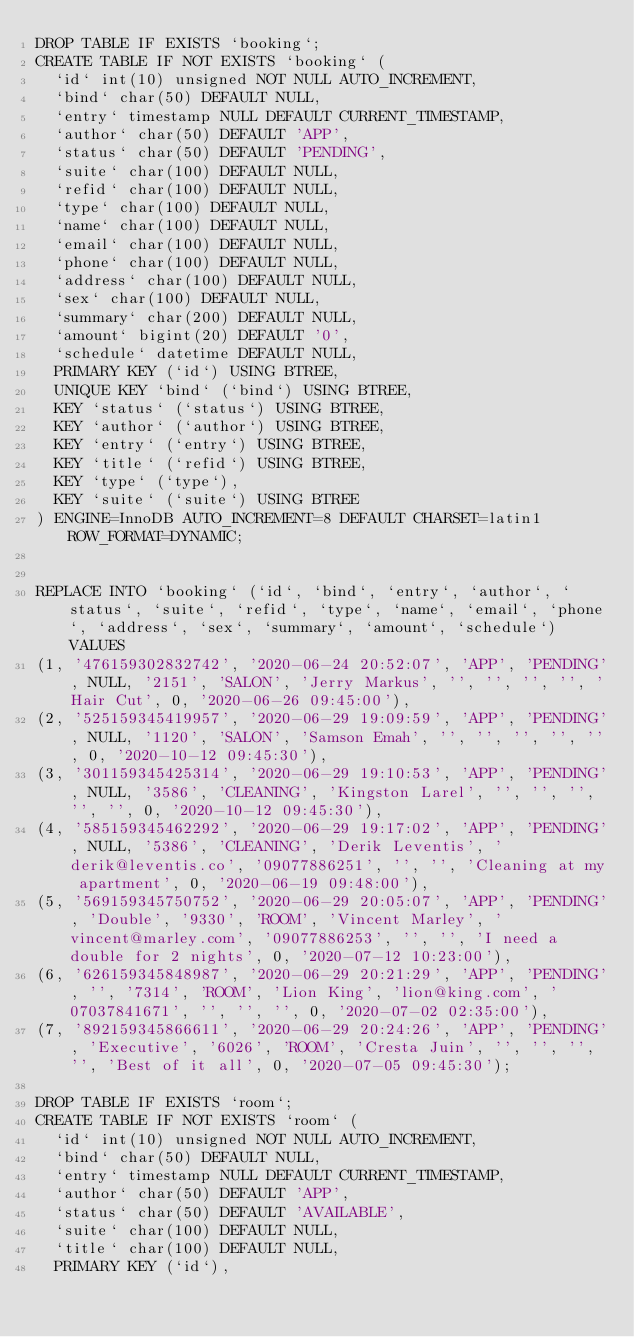<code> <loc_0><loc_0><loc_500><loc_500><_SQL_>DROP TABLE IF EXISTS `booking`;
CREATE TABLE IF NOT EXISTS `booking` (
	`id` int(10) unsigned NOT NULL AUTO_INCREMENT,
	`bind` char(50) DEFAULT NULL,
	`entry` timestamp NULL DEFAULT CURRENT_TIMESTAMP,
	`author` char(50) DEFAULT 'APP',
	`status` char(50) DEFAULT 'PENDING',
	`suite` char(100) DEFAULT NULL,
	`refid` char(100) DEFAULT NULL,
	`type` char(100) DEFAULT NULL,
	`name` char(100) DEFAULT NULL,
	`email` char(100) DEFAULT NULL,
	`phone` char(100) DEFAULT NULL,
	`address` char(100) DEFAULT NULL,
	`sex` char(100) DEFAULT NULL,
	`summary` char(200) DEFAULT NULL,
	`amount` bigint(20) DEFAULT '0',
	`schedule` datetime DEFAULT NULL,
	PRIMARY KEY (`id`) USING BTREE,
	UNIQUE KEY `bind` (`bind`) USING BTREE,
	KEY `status` (`status`) USING BTREE,
	KEY `author` (`author`) USING BTREE,
	KEY `entry` (`entry`) USING BTREE,
	KEY `title` (`refid`) USING BTREE,
	KEY `type` (`type`),
	KEY `suite` (`suite`) USING BTREE
) ENGINE=InnoDB AUTO_INCREMENT=8 DEFAULT CHARSET=latin1 ROW_FORMAT=DYNAMIC;


REPLACE INTO `booking` (`id`, `bind`, `entry`, `author`, `status`, `suite`, `refid`, `type`, `name`, `email`, `phone`, `address`, `sex`, `summary`, `amount`, `schedule`) VALUES
(1, '476159302832742', '2020-06-24 20:52:07', 'APP', 'PENDING', NULL, '2151', 'SALON', 'Jerry Markus', '', '', '', '', 'Hair Cut', 0, '2020-06-26 09:45:00'),
(2, '525159345419957', '2020-06-29 19:09:59', 'APP', 'PENDING', NULL, '1120', 'SALON', 'Samson Emah', '', '', '', '', '', 0, '2020-10-12 09:45:30'),
(3, '301159345425314', '2020-06-29 19:10:53', 'APP', 'PENDING', NULL, '3586', 'CLEANING', 'Kingston Larel', '', '', '', '', '', 0, '2020-10-12 09:45:30'),
(4, '585159345462292', '2020-06-29 19:17:02', 'APP', 'PENDING', NULL, '5386', 'CLEANING', 'Derik Leventis', 'derik@leventis.co', '09077886251', '', '', 'Cleaning at my apartment', 0, '2020-06-19 09:48:00'),
(5, '569159345750752', '2020-06-29 20:05:07', 'APP', 'PENDING', 'Double', '9330', 'ROOM', 'Vincent Marley', 'vincent@marley.com', '09077886253', '', '', 'I need a double for 2 nights', 0, '2020-07-12 10:23:00'),
(6, '626159345848987', '2020-06-29 20:21:29', 'APP', 'PENDING', '', '7314', 'ROOM', 'Lion King', 'lion@king.com', '07037841671', '', '', '', 0, '2020-07-02 02:35:00'),
(7, '892159345866611', '2020-06-29 20:24:26', 'APP', 'PENDING', 'Executive', '6026', 'ROOM', 'Cresta Juin', '', '', '', '', 'Best of it all', 0, '2020-07-05 09:45:30');

DROP TABLE IF EXISTS `room`;
CREATE TABLE IF NOT EXISTS `room` (
	`id` int(10) unsigned NOT NULL AUTO_INCREMENT,
	`bind` char(50) DEFAULT NULL,
	`entry` timestamp NULL DEFAULT CURRENT_TIMESTAMP,
	`author` char(50) DEFAULT 'APP',
	`status` char(50) DEFAULT 'AVAILABLE',
	`suite` char(100) DEFAULT NULL,
	`title` char(100) DEFAULT NULL,
	PRIMARY KEY (`id`),</code> 